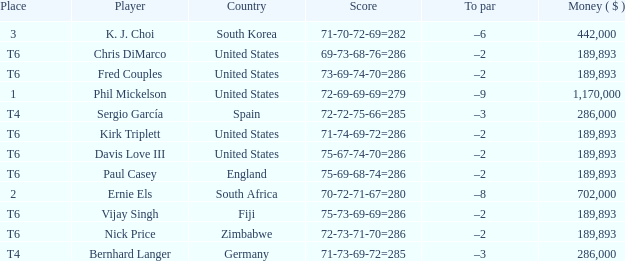What is the Money ($) when the Place is t6, and Player is chris dimarco? 189893.0. 